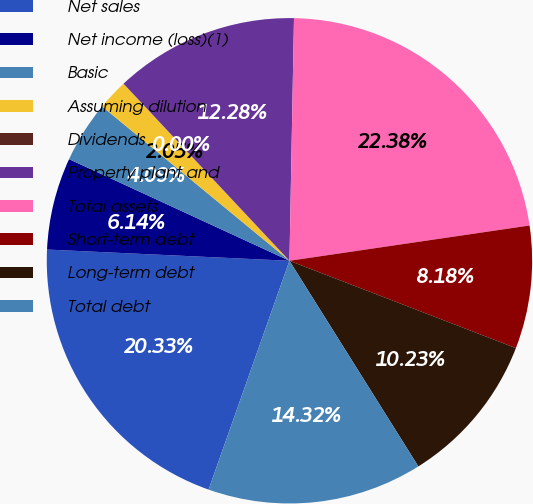<chart> <loc_0><loc_0><loc_500><loc_500><pie_chart><fcel>Net sales<fcel>Net income (loss)(1)<fcel>Basic<fcel>Assuming dilution<fcel>Dividends<fcel>Property plant and<fcel>Total assets<fcel>Short-term debt<fcel>Long-term debt<fcel>Total debt<nl><fcel>20.33%<fcel>6.14%<fcel>4.09%<fcel>2.05%<fcel>0.0%<fcel>12.28%<fcel>22.38%<fcel>8.18%<fcel>10.23%<fcel>14.32%<nl></chart> 